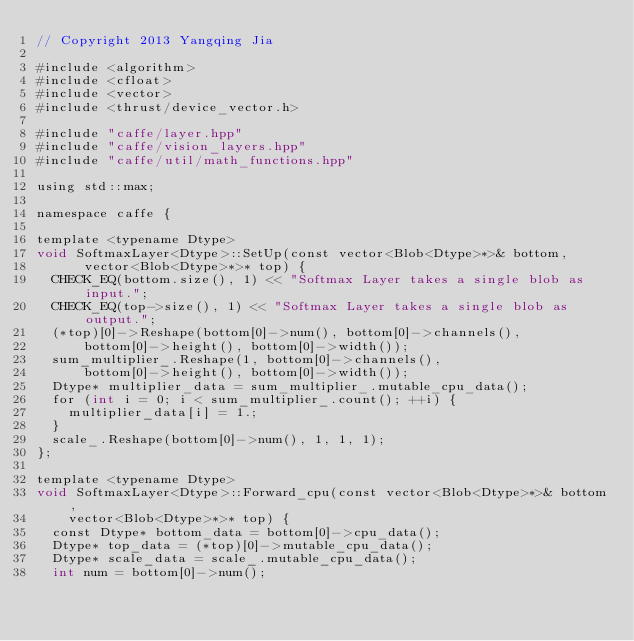<code> <loc_0><loc_0><loc_500><loc_500><_Cuda_>// Copyright 2013 Yangqing Jia

#include <algorithm>
#include <cfloat>
#include <vector>
#include <thrust/device_vector.h>

#include "caffe/layer.hpp"
#include "caffe/vision_layers.hpp"
#include "caffe/util/math_functions.hpp"

using std::max;

namespace caffe {

template <typename Dtype>
void SoftmaxLayer<Dtype>::SetUp(const vector<Blob<Dtype>*>& bottom,
      vector<Blob<Dtype>*>* top) {
  CHECK_EQ(bottom.size(), 1) << "Softmax Layer takes a single blob as input.";
  CHECK_EQ(top->size(), 1) << "Softmax Layer takes a single blob as output.";
  (*top)[0]->Reshape(bottom[0]->num(), bottom[0]->channels(),
      bottom[0]->height(), bottom[0]->width());
  sum_multiplier_.Reshape(1, bottom[0]->channels(),
      bottom[0]->height(), bottom[0]->width());
  Dtype* multiplier_data = sum_multiplier_.mutable_cpu_data();
  for (int i = 0; i < sum_multiplier_.count(); ++i) {
    multiplier_data[i] = 1.;
  }
  scale_.Reshape(bottom[0]->num(), 1, 1, 1);
};

template <typename Dtype>
void SoftmaxLayer<Dtype>::Forward_cpu(const vector<Blob<Dtype>*>& bottom,
    vector<Blob<Dtype>*>* top) {
  const Dtype* bottom_data = bottom[0]->cpu_data();
  Dtype* top_data = (*top)[0]->mutable_cpu_data();
  Dtype* scale_data = scale_.mutable_cpu_data();
  int num = bottom[0]->num();</code> 